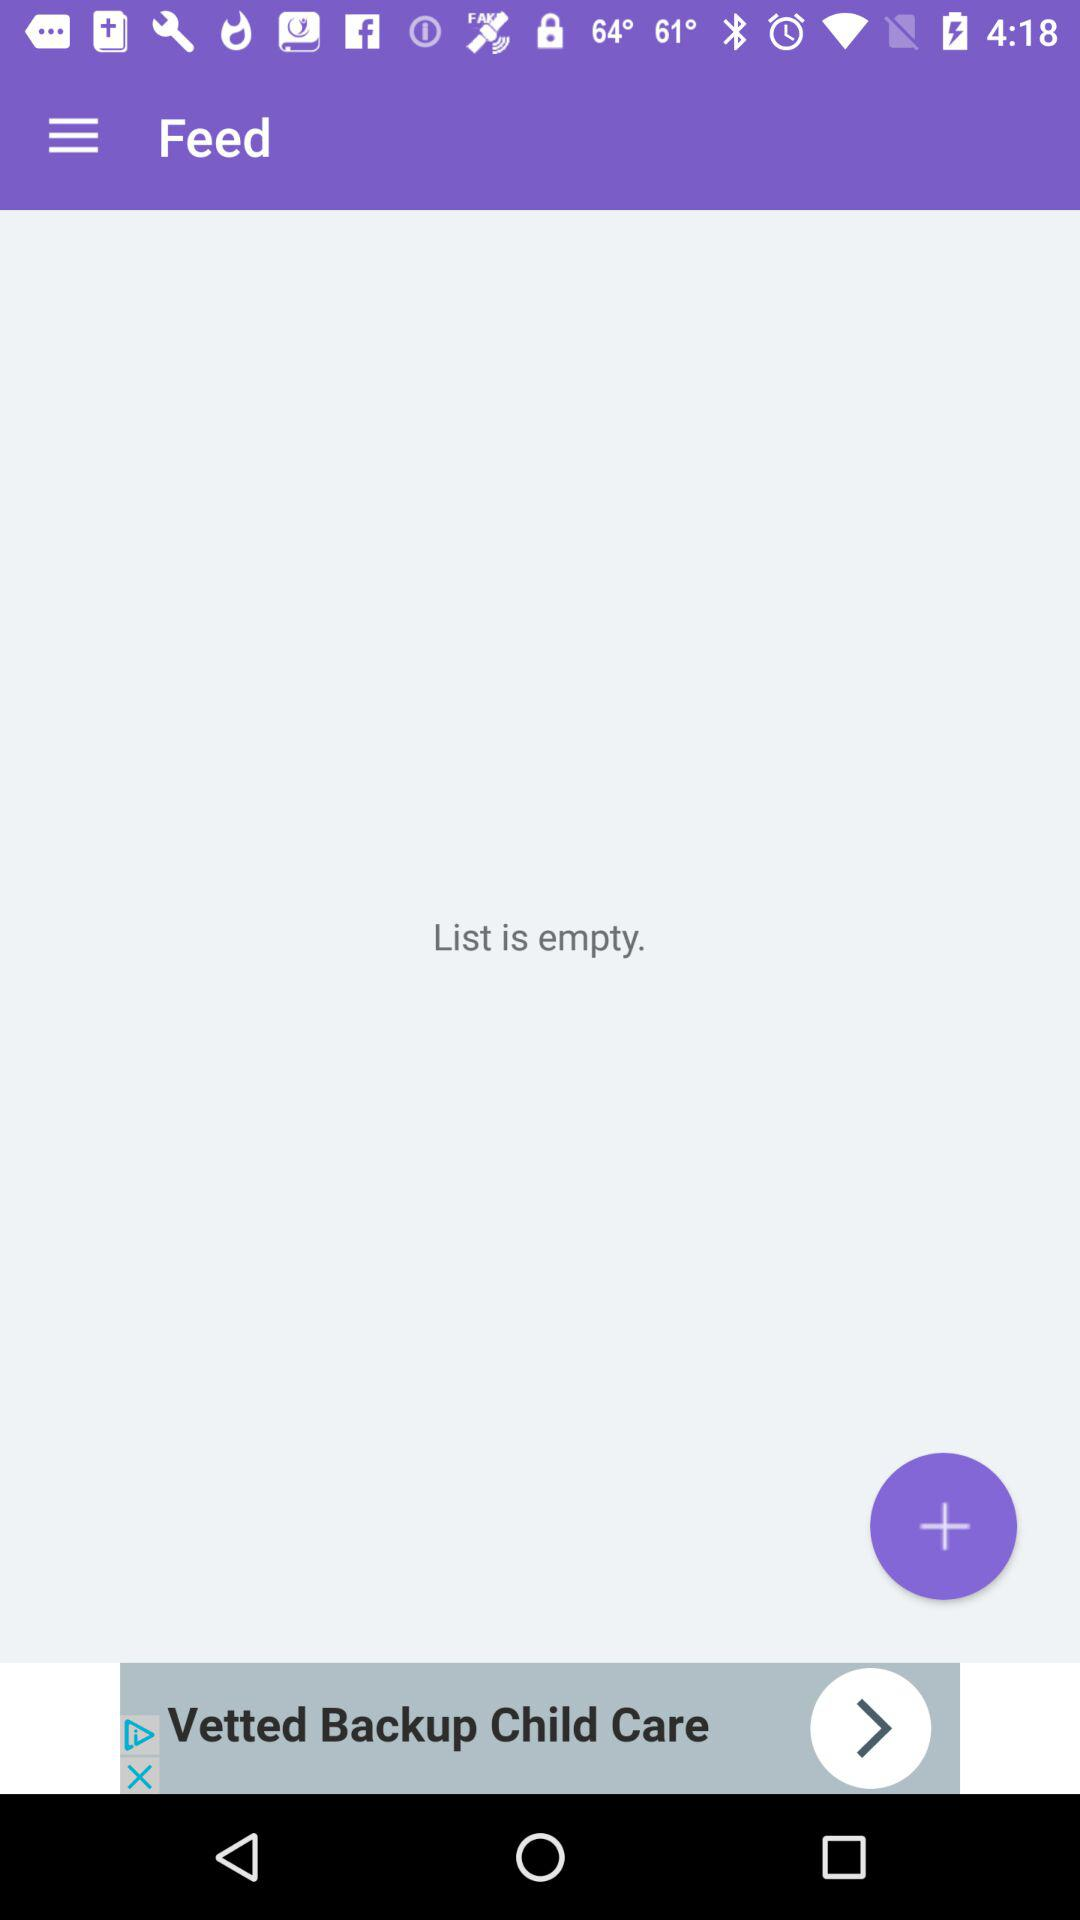Is the list filled? The list is empty. 